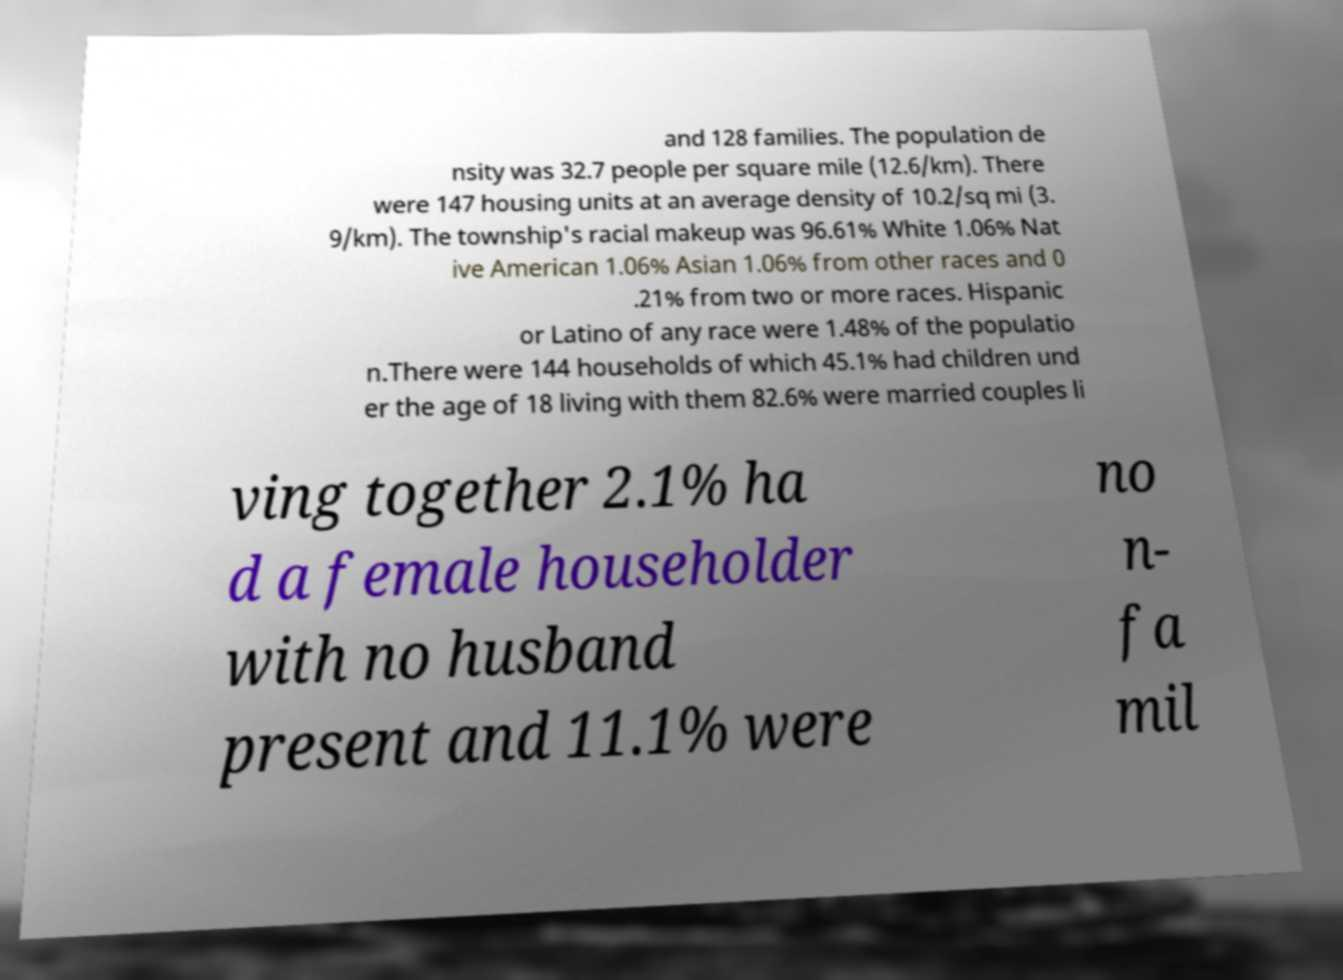What messages or text are displayed in this image? I need them in a readable, typed format. and 128 families. The population de nsity was 32.7 people per square mile (12.6/km). There were 147 housing units at an average density of 10.2/sq mi (3. 9/km). The township's racial makeup was 96.61% White 1.06% Nat ive American 1.06% Asian 1.06% from other races and 0 .21% from two or more races. Hispanic or Latino of any race were 1.48% of the populatio n.There were 144 households of which 45.1% had children und er the age of 18 living with them 82.6% were married couples li ving together 2.1% ha d a female householder with no husband present and 11.1% were no n- fa mil 